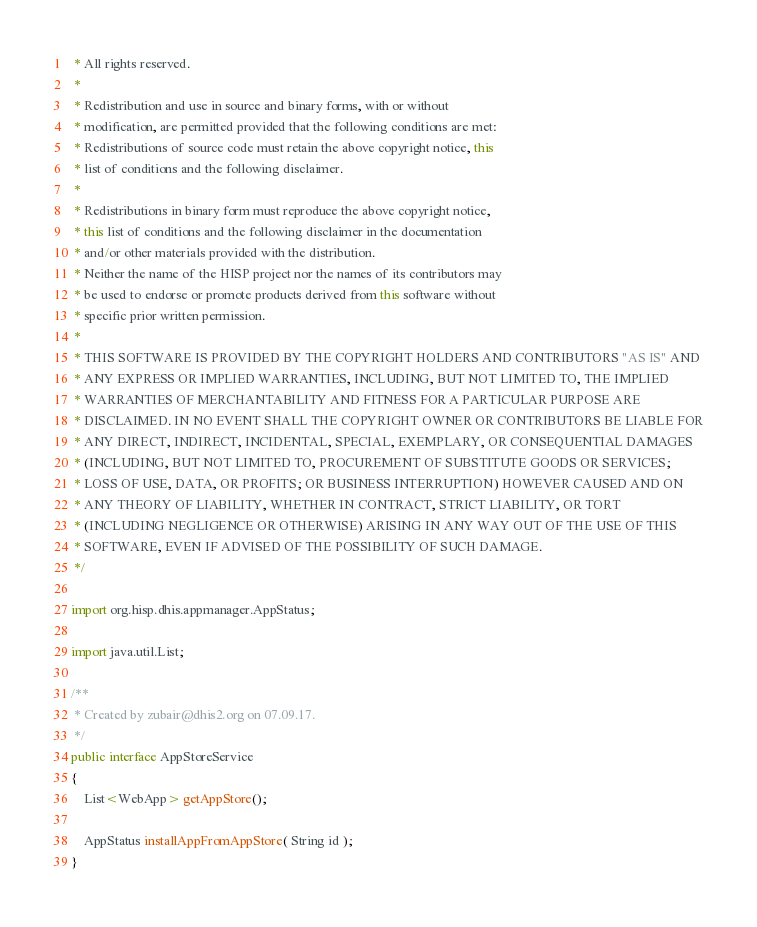Convert code to text. <code><loc_0><loc_0><loc_500><loc_500><_Java_> * All rights reserved.
 *
 * Redistribution and use in source and binary forms, with or without
 * modification, are permitted provided that the following conditions are met:
 * Redistributions of source code must retain the above copyright notice, this
 * list of conditions and the following disclaimer.
 *
 * Redistributions in binary form must reproduce the above copyright notice,
 * this list of conditions and the following disclaimer in the documentation
 * and/or other materials provided with the distribution.
 * Neither the name of the HISP project nor the names of its contributors may
 * be used to endorse or promote products derived from this software without
 * specific prior written permission.
 *
 * THIS SOFTWARE IS PROVIDED BY THE COPYRIGHT HOLDERS AND CONTRIBUTORS "AS IS" AND
 * ANY EXPRESS OR IMPLIED WARRANTIES, INCLUDING, BUT NOT LIMITED TO, THE IMPLIED
 * WARRANTIES OF MERCHANTABILITY AND FITNESS FOR A PARTICULAR PURPOSE ARE
 * DISCLAIMED. IN NO EVENT SHALL THE COPYRIGHT OWNER OR CONTRIBUTORS BE LIABLE FOR
 * ANY DIRECT, INDIRECT, INCIDENTAL, SPECIAL, EXEMPLARY, OR CONSEQUENTIAL DAMAGES
 * (INCLUDING, BUT NOT LIMITED TO, PROCUREMENT OF SUBSTITUTE GOODS OR SERVICES;
 * LOSS OF USE, DATA, OR PROFITS; OR BUSINESS INTERRUPTION) HOWEVER CAUSED AND ON
 * ANY THEORY OF LIABILITY, WHETHER IN CONTRACT, STRICT LIABILITY, OR TORT
 * (INCLUDING NEGLIGENCE OR OTHERWISE) ARISING IN ANY WAY OUT OF THE USE OF THIS
 * SOFTWARE, EVEN IF ADVISED OF THE POSSIBILITY OF SUCH DAMAGE.
 */

import org.hisp.dhis.appmanager.AppStatus;

import java.util.List;

/**
 * Created by zubair@dhis2.org on 07.09.17.
 */
public interface AppStoreService
{
    List<WebApp> getAppStore();

    AppStatus installAppFromAppStore( String id );
}
</code> 